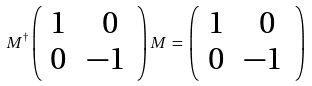<formula> <loc_0><loc_0><loc_500><loc_500>M ^ { \dagger } \left ( \begin{array} { c c } { 1 \, } & { \, 0 } \\ { 0 \, } & { - 1 \, } \end{array} \right ) M \, = \, \left ( \begin{array} { c c } { 1 \, } & { \, 0 } \\ { 0 \, } & { - 1 \, } \end{array} \right ) \,</formula> 